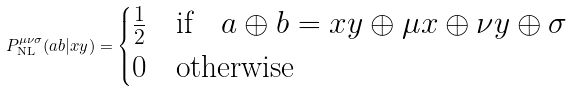<formula> <loc_0><loc_0><loc_500><loc_500>P _ { \text {NL} } ^ { \mu \nu \sigma } ( a b | x y ) = \begin{cases} \frac { 1 } { 2 } & \text {if} \quad \text {$a \oplus b = xy\oplus\mu x\oplus\nu y\oplus\sigma $} \\ 0 & \text {otherwise} \end{cases}</formula> 